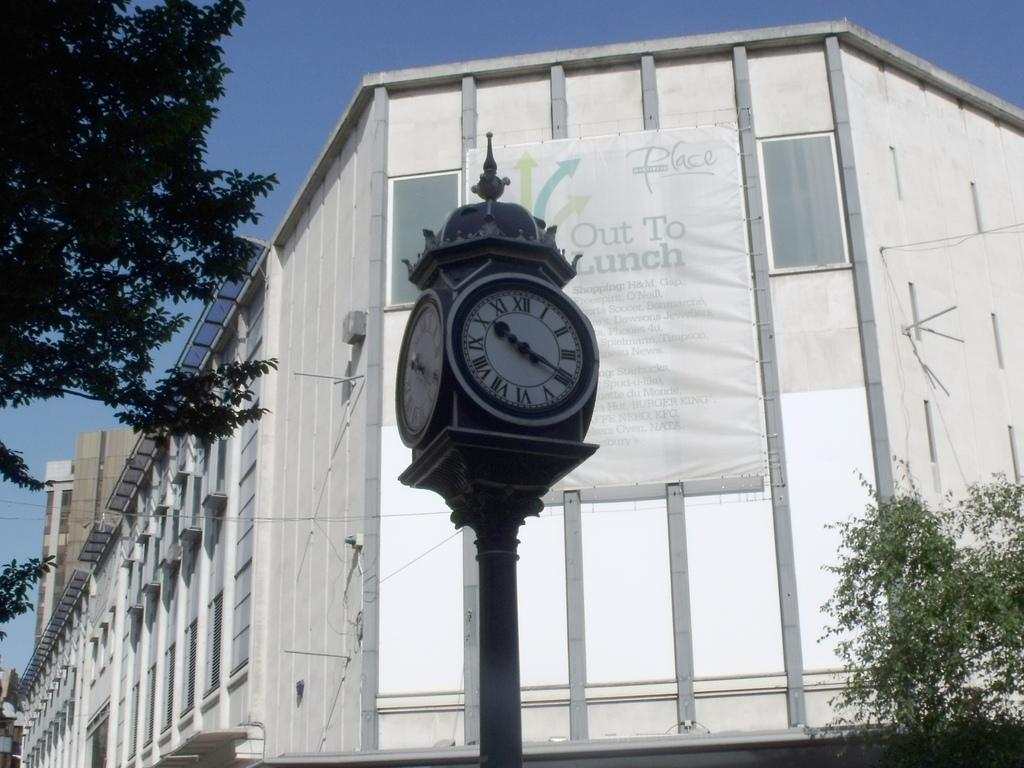<image>
Relay a brief, clear account of the picture shown. High on the side of a building is a sign about being out to lunch. 